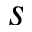Convert formula to latex. <formula><loc_0><loc_0><loc_500><loc_500>s</formula> 